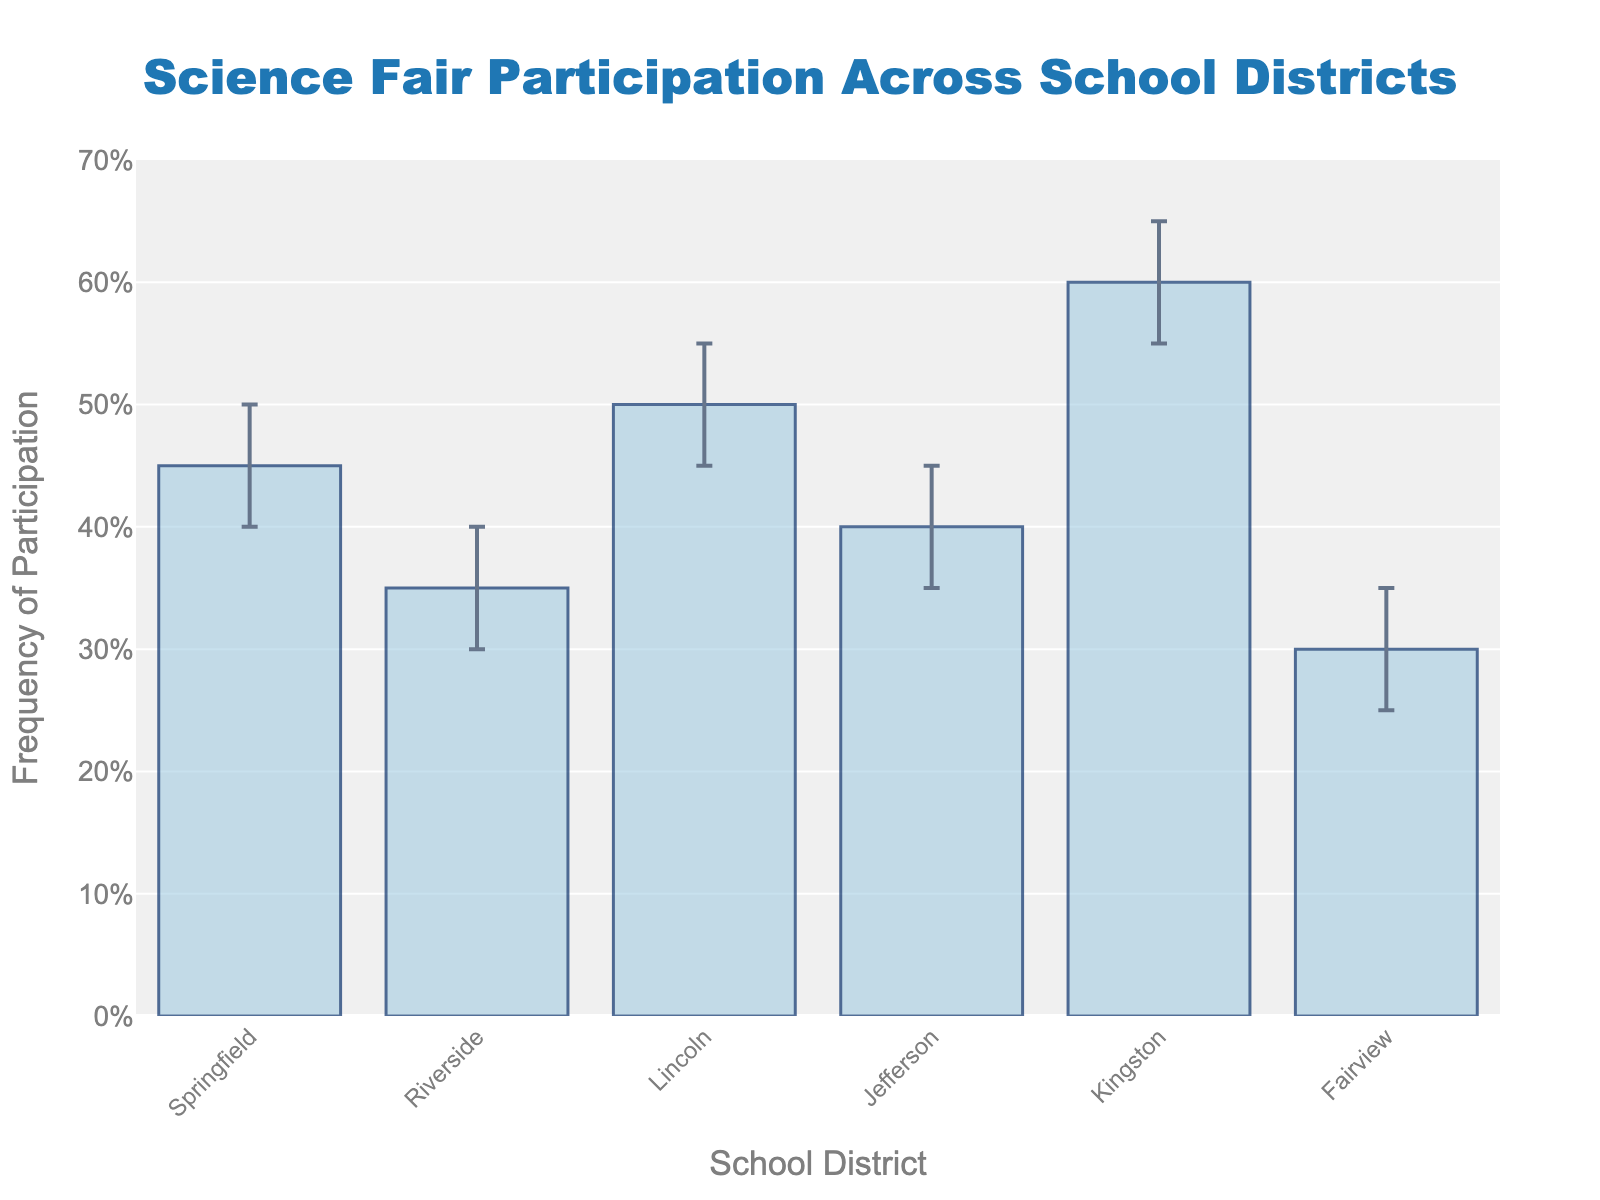What is the title of the figure? The title of the figure is located at the top center of the plot. It summarizes the content of the data visualization. The title in this case is "Science Fair Participation Across School Districts."
Answer: Science Fair Participation Across School Districts Which school district has the highest frequency of participation? By observing the heights of the bars, the school district with the tallest bar represents the highest frequency of participation. Kingston has the tallest bar.
Answer: Kingston What is the frequency of participation for Riverside? The height of the bar for Riverside represents its frequency of participation. The corresponding data point for Riverside is 0.35.
Answer: 0.35 How do the confidence intervals of Jefferson compare to those of Lincoln? To compare, observe the range of the error bars for each district. The lower and upper bounds for Lincoln are 0.45 and 0.55, respectively, while for Jefferson, they are 0.35 and 0.45. Jefferson's confidence interval is narrower.
Answer: Jefferson's confidence interval is narrower Which school district has the narrowest confidence interval? The narrowness of a confidence interval can be determined by the difference between the upper and lower bounds of the error bars. For Fairview, this difference is 0.10 (0.35 - 0.25), which is the smallest among all districts.
Answer: Fairview Which school district has the lowest frequency of participation and what is it? The school district with the shortest bar indicates the lowest frequency of participation. Fairview's bar is the shortest, and its frequency is 0.30.
Answer: Fairview, 0.30 Which school districts have overlapping confidence intervals between 0.40 to 0.45? Confidence intervals overlap when their ranges intersect. Lincoln's interval (0.45-0.55), Jefferson's interval (0.35-0.45), Springfield's interval (0.40-0.50), and Riverside's interval (0.30-0.40) overlap within the 0.40 to 0.45 range.
Answer: Lincoln, Jefferson, Springfield How much higher is Kingston's frequency of participation compared to Riverside's? Subtract Riverside's participation frequency from Kingston's. Kingston: 0.60 and Riverside: 0.35, so the difference is 0.60 - 0.35 = 0.25.
Answer: 0.25 Which school district has the highest upper bound in their confidence interval and what is the value? The upper limit of the error bars represents the highest value in a confidence interval. Kingston reaches the highest at 0.65.
Answer: Kingston, 0.65 What is the mean frequency of participation for all the school districts? Add all frequencies and divide by the number of districts: (0.45 + 0.35 + 0.50 + 0.40 + 0.60 + 0.30) / 6 = 2.60 / 6 = approximately 0.433.
Answer: 0.433 